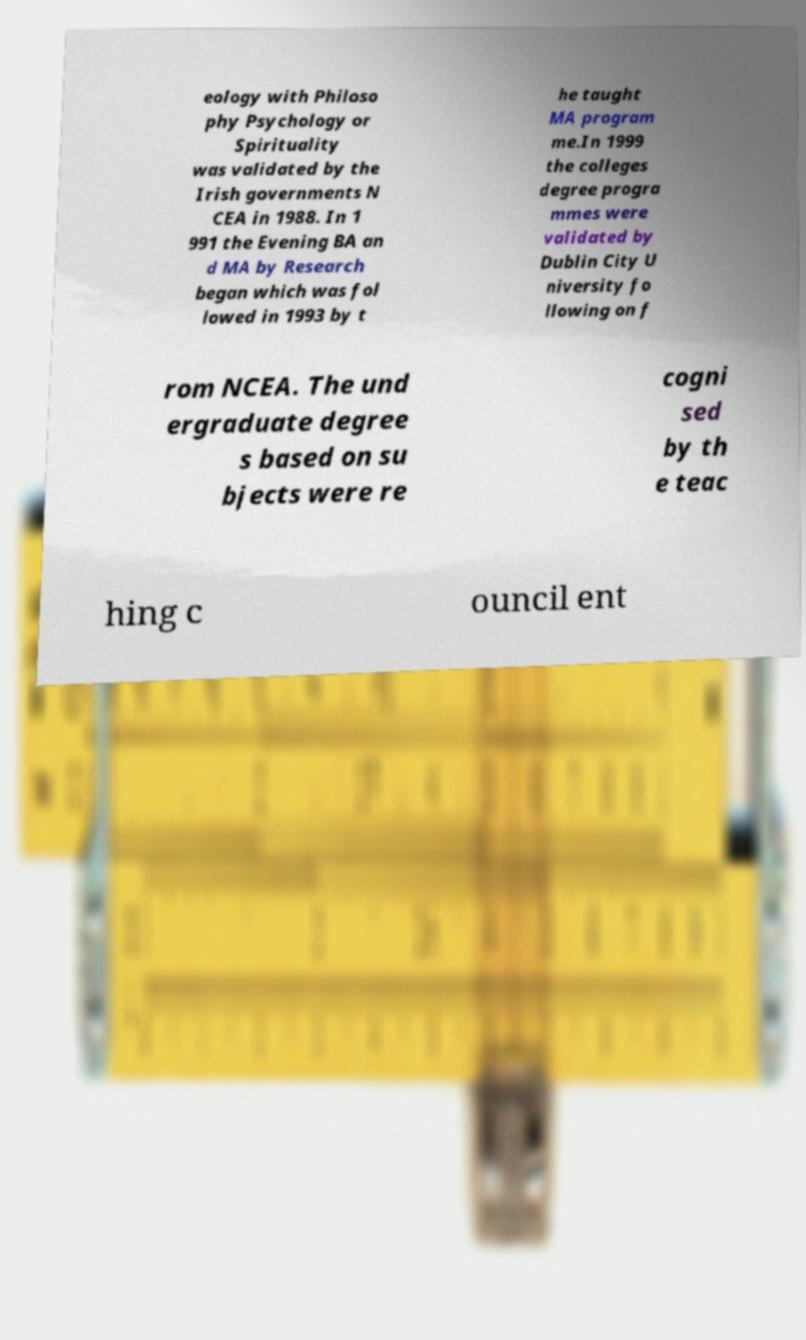What messages or text are displayed in this image? I need them in a readable, typed format. eology with Philoso phy Psychology or Spirituality was validated by the Irish governments N CEA in 1988. In 1 991 the Evening BA an d MA by Research began which was fol lowed in 1993 by t he taught MA program me.In 1999 the colleges degree progra mmes were validated by Dublin City U niversity fo llowing on f rom NCEA. The und ergraduate degree s based on su bjects were re cogni sed by th e teac hing c ouncil ent 